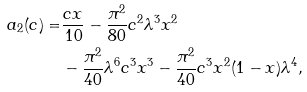<formula> <loc_0><loc_0><loc_500><loc_500>a _ { 2 } ( c ) = & \frac { c x } { 1 0 } - \frac { \pi ^ { 2 } } { 8 0 } c ^ { 2 } \lambda ^ { 3 } x ^ { 2 } \\ & - \frac { \pi ^ { 2 } } { 4 0 } \lambda ^ { 6 } c ^ { 3 } x ^ { 3 } - \frac { \pi ^ { 2 } } { 4 0 } c ^ { 3 } x ^ { 2 } ( 1 - x ) \lambda ^ { 4 } ,</formula> 